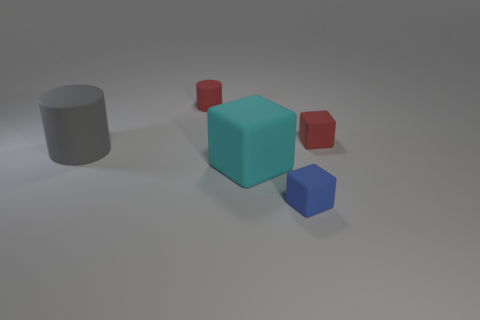Subtract all gray cubes. Subtract all brown spheres. How many cubes are left? 3 Add 5 cubes. How many objects exist? 10 Subtract all blocks. How many objects are left? 2 Subtract 0 brown spheres. How many objects are left? 5 Subtract all rubber blocks. Subtract all tiny blue blocks. How many objects are left? 1 Add 3 blue rubber things. How many blue rubber things are left? 4 Add 1 large cyan rubber spheres. How many large cyan rubber spheres exist? 1 